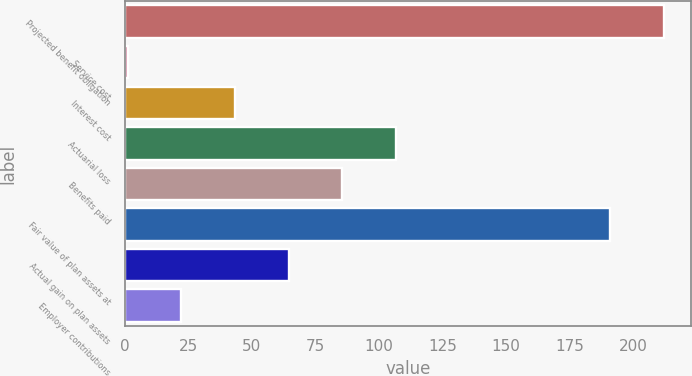Convert chart. <chart><loc_0><loc_0><loc_500><loc_500><bar_chart><fcel>Projected benefit obligation<fcel>Service cost<fcel>Interest cost<fcel>Actuarial loss<fcel>Benefits paid<fcel>Fair value of plan assets at<fcel>Actual gain on plan assets<fcel>Employer contributions<nl><fcel>212.1<fcel>1.1<fcel>43.3<fcel>106.6<fcel>85.5<fcel>191<fcel>64.4<fcel>22.2<nl></chart> 